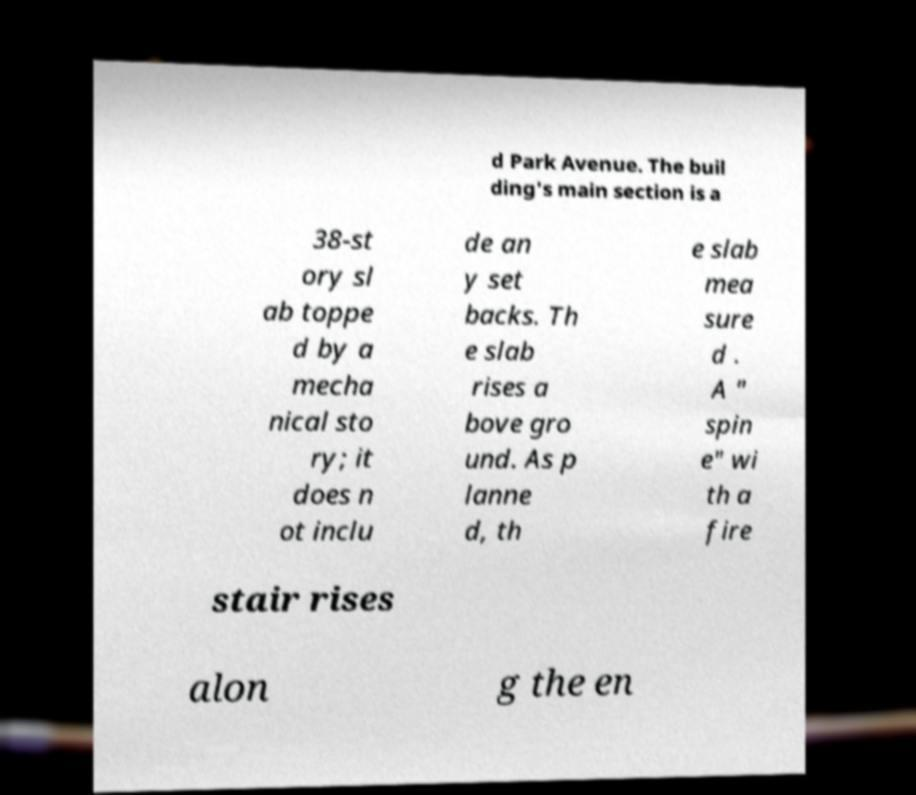Could you extract and type out the text from this image? d Park Avenue. The buil ding's main section is a 38-st ory sl ab toppe d by a mecha nical sto ry; it does n ot inclu de an y set backs. Th e slab rises a bove gro und. As p lanne d, th e slab mea sure d . A " spin e" wi th a fire stair rises alon g the en 